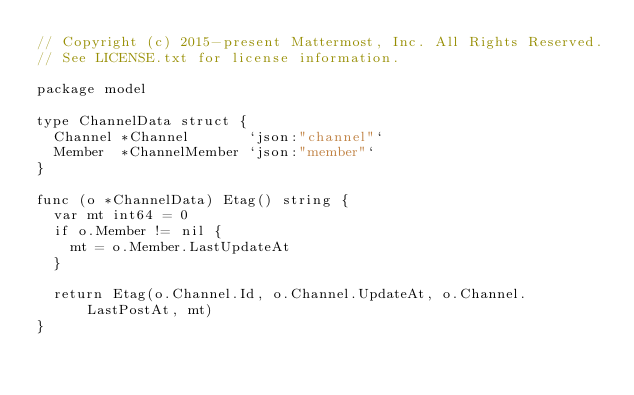Convert code to text. <code><loc_0><loc_0><loc_500><loc_500><_Go_>// Copyright (c) 2015-present Mattermost, Inc. All Rights Reserved.
// See LICENSE.txt for license information.

package model

type ChannelData struct {
	Channel *Channel       `json:"channel"`
	Member  *ChannelMember `json:"member"`
}

func (o *ChannelData) Etag() string {
	var mt int64 = 0
	if o.Member != nil {
		mt = o.Member.LastUpdateAt
	}

	return Etag(o.Channel.Id, o.Channel.UpdateAt, o.Channel.LastPostAt, mt)
}
</code> 